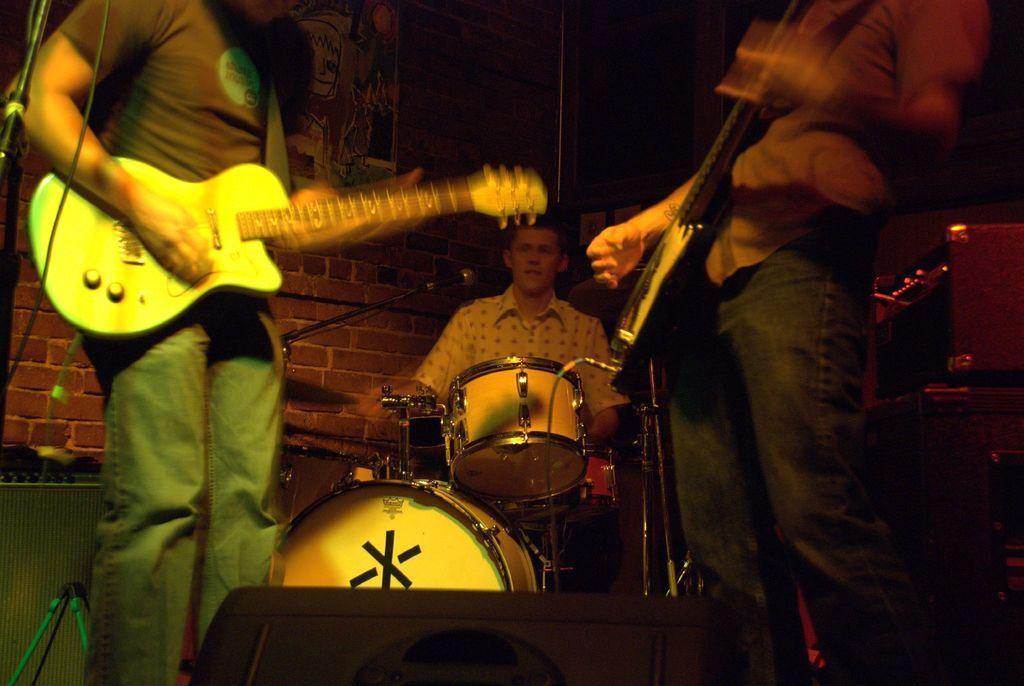Describe this image in one or two sentences. In this image, we can see three people are playing musical instruments. At the bottom of the image, we can see a black color object. Background there is a brick wall, some poster. Here we can see few strands and microphone. 